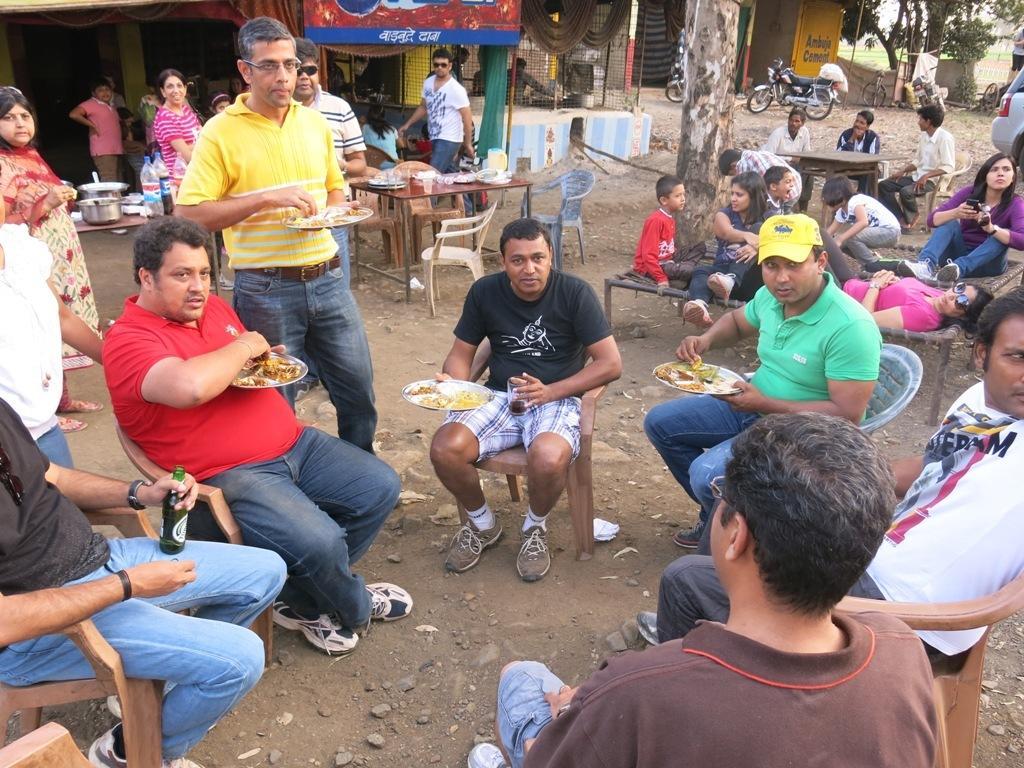Can you describe this image briefly? In this picture there is a group of persons were sitting on the chair and they are eating the food. On the right I can see some children and women were sitting and lying on the bed. In the back I can see many people were standing in front of the store. On the table I can see water glass, plates, water bottles. coke bottles, covers and other objects. On the top right corner I can see the bikes and bicycle which are parked near to the gate and fencing. Beside that I can see the grass and trees. In the background there is a sky. 